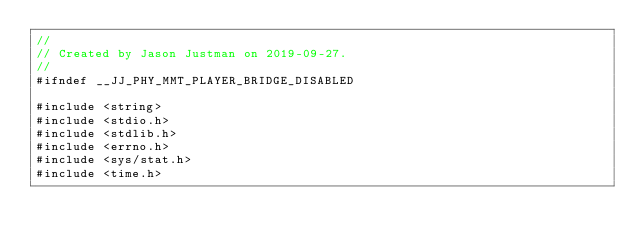Convert code to text. <code><loc_0><loc_0><loc_500><loc_500><_C_>//
// Created by Jason Justman on 2019-09-27.
//
#ifndef __JJ_PHY_MMT_PLAYER_BRIDGE_DISABLED

#include <string>
#include <stdio.h>
#include <stdlib.h>
#include <errno.h>
#include <sys/stat.h>
#include <time.h></code> 